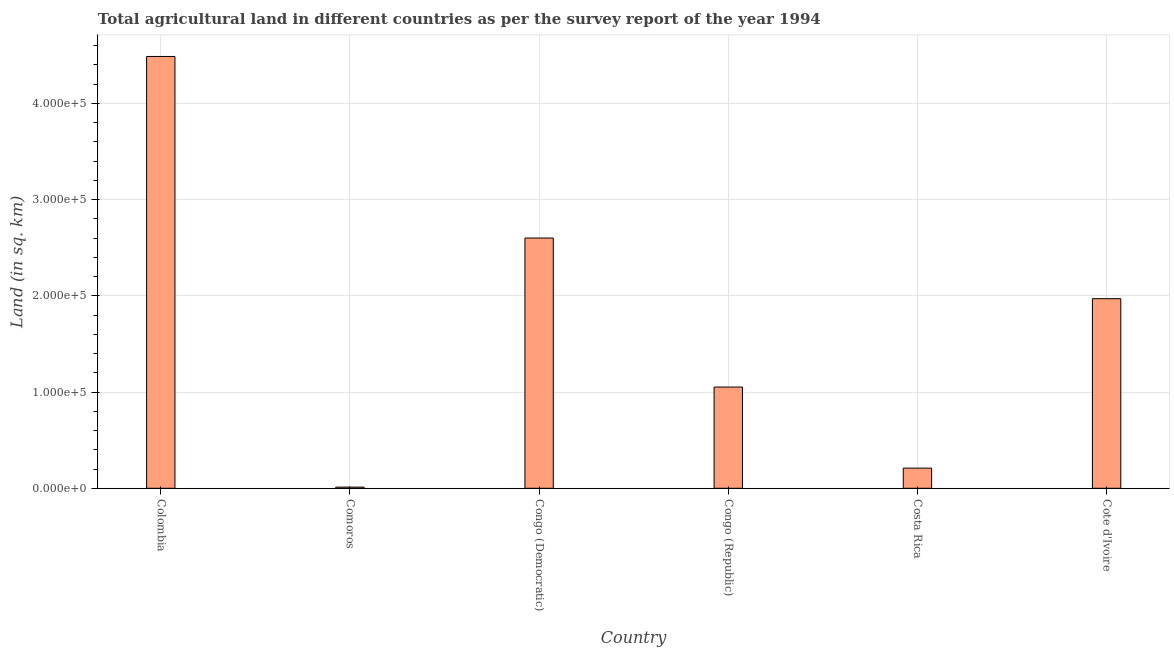Does the graph contain any zero values?
Offer a terse response. No. What is the title of the graph?
Ensure brevity in your answer.  Total agricultural land in different countries as per the survey report of the year 1994. What is the label or title of the X-axis?
Offer a terse response. Country. What is the label or title of the Y-axis?
Your answer should be very brief. Land (in sq. km). What is the agricultural land in Cote d'Ivoire?
Keep it short and to the point. 1.97e+05. Across all countries, what is the maximum agricultural land?
Provide a succinct answer. 4.49e+05. Across all countries, what is the minimum agricultural land?
Provide a short and direct response. 1200. In which country was the agricultural land maximum?
Keep it short and to the point. Colombia. In which country was the agricultural land minimum?
Offer a very short reply. Comoros. What is the sum of the agricultural land?
Offer a terse response. 1.03e+06. What is the difference between the agricultural land in Comoros and Costa Rica?
Ensure brevity in your answer.  -1.98e+04. What is the average agricultural land per country?
Keep it short and to the point. 1.72e+05. What is the median agricultural land?
Offer a terse response. 1.51e+05. What is the ratio of the agricultural land in Colombia to that in Congo (Republic)?
Your answer should be very brief. 4.27. Is the agricultural land in Comoros less than that in Congo (Democratic)?
Provide a short and direct response. Yes. What is the difference between the highest and the second highest agricultural land?
Keep it short and to the point. 1.89e+05. Is the sum of the agricultural land in Congo (Democratic) and Congo (Republic) greater than the maximum agricultural land across all countries?
Offer a very short reply. No. What is the difference between the highest and the lowest agricultural land?
Offer a very short reply. 4.47e+05. Are all the bars in the graph horizontal?
Your answer should be very brief. No. How many countries are there in the graph?
Your answer should be very brief. 6. Are the values on the major ticks of Y-axis written in scientific E-notation?
Ensure brevity in your answer.  Yes. What is the Land (in sq. km) of Colombia?
Ensure brevity in your answer.  4.49e+05. What is the Land (in sq. km) of Comoros?
Your answer should be compact. 1200. What is the Land (in sq. km) in Congo (Democratic)?
Your answer should be very brief. 2.60e+05. What is the Land (in sq. km) in Congo (Republic)?
Make the answer very short. 1.05e+05. What is the Land (in sq. km) of Costa Rica?
Your response must be concise. 2.10e+04. What is the Land (in sq. km) of Cote d'Ivoire?
Provide a succinct answer. 1.97e+05. What is the difference between the Land (in sq. km) in Colombia and Comoros?
Your answer should be compact. 4.47e+05. What is the difference between the Land (in sq. km) in Colombia and Congo (Democratic)?
Offer a very short reply. 1.89e+05. What is the difference between the Land (in sq. km) in Colombia and Congo (Republic)?
Make the answer very short. 3.43e+05. What is the difference between the Land (in sq. km) in Colombia and Costa Rica?
Make the answer very short. 4.28e+05. What is the difference between the Land (in sq. km) in Colombia and Cote d'Ivoire?
Offer a very short reply. 2.52e+05. What is the difference between the Land (in sq. km) in Comoros and Congo (Democratic)?
Your answer should be very brief. -2.59e+05. What is the difference between the Land (in sq. km) in Comoros and Congo (Republic)?
Ensure brevity in your answer.  -1.04e+05. What is the difference between the Land (in sq. km) in Comoros and Costa Rica?
Your answer should be very brief. -1.98e+04. What is the difference between the Land (in sq. km) in Comoros and Cote d'Ivoire?
Your answer should be compact. -1.96e+05. What is the difference between the Land (in sq. km) in Congo (Democratic) and Congo (Republic)?
Keep it short and to the point. 1.55e+05. What is the difference between the Land (in sq. km) in Congo (Democratic) and Costa Rica?
Your response must be concise. 2.39e+05. What is the difference between the Land (in sq. km) in Congo (Democratic) and Cote d'Ivoire?
Keep it short and to the point. 6.30e+04. What is the difference between the Land (in sq. km) in Congo (Republic) and Costa Rica?
Your answer should be compact. 8.42e+04. What is the difference between the Land (in sq. km) in Congo (Republic) and Cote d'Ivoire?
Your response must be concise. -9.18e+04. What is the difference between the Land (in sq. km) in Costa Rica and Cote d'Ivoire?
Your answer should be very brief. -1.76e+05. What is the ratio of the Land (in sq. km) in Colombia to that in Comoros?
Offer a very short reply. 373.88. What is the ratio of the Land (in sq. km) in Colombia to that in Congo (Democratic)?
Offer a terse response. 1.73. What is the ratio of the Land (in sq. km) in Colombia to that in Congo (Republic)?
Keep it short and to the point. 4.27. What is the ratio of the Land (in sq. km) in Colombia to that in Costa Rica?
Your response must be concise. 21.41. What is the ratio of the Land (in sq. km) in Colombia to that in Cote d'Ivoire?
Offer a very short reply. 2.28. What is the ratio of the Land (in sq. km) in Comoros to that in Congo (Democratic)?
Provide a succinct answer. 0.01. What is the ratio of the Land (in sq. km) in Comoros to that in Congo (Republic)?
Offer a very short reply. 0.01. What is the ratio of the Land (in sq. km) in Comoros to that in Costa Rica?
Offer a very short reply. 0.06. What is the ratio of the Land (in sq. km) in Comoros to that in Cote d'Ivoire?
Give a very brief answer. 0.01. What is the ratio of the Land (in sq. km) in Congo (Democratic) to that in Congo (Republic)?
Offer a terse response. 2.47. What is the ratio of the Land (in sq. km) in Congo (Democratic) to that in Costa Rica?
Provide a short and direct response. 12.41. What is the ratio of the Land (in sq. km) in Congo (Democratic) to that in Cote d'Ivoire?
Make the answer very short. 1.32. What is the ratio of the Land (in sq. km) in Congo (Republic) to that in Costa Rica?
Make the answer very short. 5.02. What is the ratio of the Land (in sq. km) in Congo (Republic) to that in Cote d'Ivoire?
Ensure brevity in your answer.  0.53. What is the ratio of the Land (in sq. km) in Costa Rica to that in Cote d'Ivoire?
Your answer should be very brief. 0.11. 